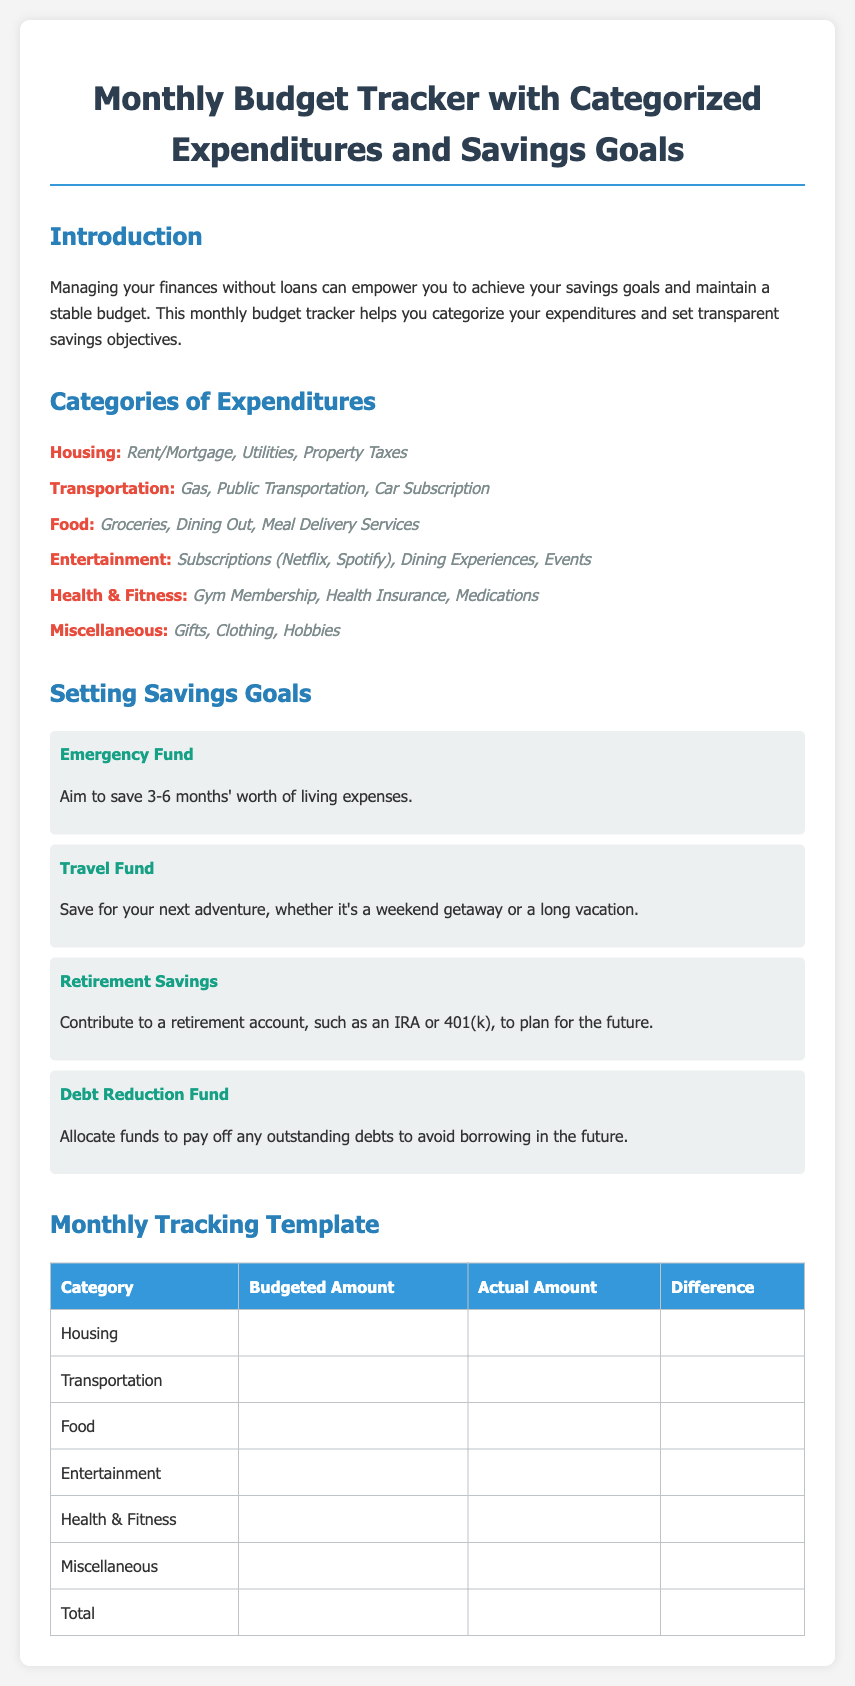What are the categories of expenditures? The categories of expenditures are listed under "Categories of Expenditures" in the document, including Housing, Transportation, Food, Entertainment, Health & Fitness, and Miscellaneous.
Answer: Housing, Transportation, Food, Entertainment, Health & Fitness, Miscellaneous What is the purpose of the Monthly Budget Tracker? The purpose of the Monthly Budget Tracker is outlined in the introduction, stating it helps manage finances without loans and supports achieving savings goals.
Answer: Manage finances without loans What is the recommended savings for an emergency fund? The document specifies that the savings goal for an emergency fund should be 3-6 months' worth of living expenses.
Answer: 3-6 months How many categories of expenditures are listed? The number of categories can be counted in the document, and there are six categories listed in total.
Answer: Six What does the "Debt Reduction Fund" goal pertain to? The goal pertains to allocating funds to pay off any outstanding debts, promoting a loan-free future.
Answer: Pay off outstanding debts What is the visual style used for the cost categories in the table? The table headings and content use specific styling to distinguish between categories and amounts, which is structured across categories, budgeted amounts, actual amounts, and differences.
Answer: Styled table What type of membership is mentioned under Health & Fitness? The document mentions "Gym Membership" as part of the Health & Fitness category.
Answer: Gym Membership What is the color used for the goal titles? The color for the goal titles is noted as "16a085" in the styling section, which corresponds to a shade of teal or green for emphasis.
Answer: Teal What are examples of expenditures under Food? The examples listed in the Food category include Groceries, Dining Out, and Meal Delivery Services.
Answer: Groceries, Dining Out, Meal Delivery Services 